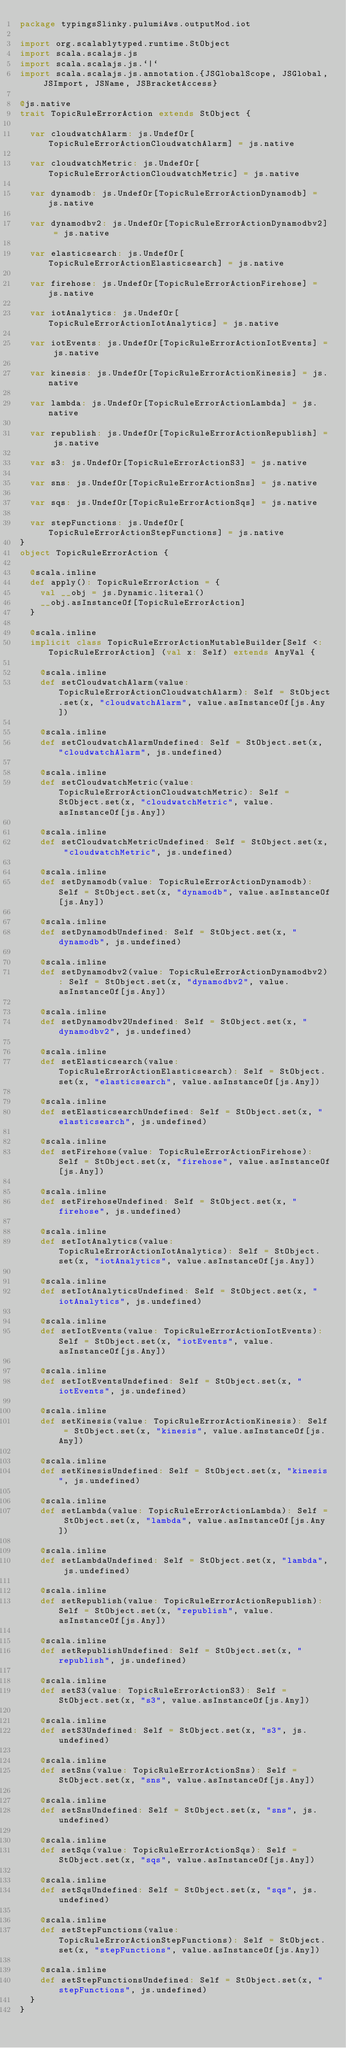Convert code to text. <code><loc_0><loc_0><loc_500><loc_500><_Scala_>package typingsSlinky.pulumiAws.outputMod.iot

import org.scalablytyped.runtime.StObject
import scala.scalajs.js
import scala.scalajs.js.`|`
import scala.scalajs.js.annotation.{JSGlobalScope, JSGlobal, JSImport, JSName, JSBracketAccess}

@js.native
trait TopicRuleErrorAction extends StObject {
  
  var cloudwatchAlarm: js.UndefOr[TopicRuleErrorActionCloudwatchAlarm] = js.native
  
  var cloudwatchMetric: js.UndefOr[TopicRuleErrorActionCloudwatchMetric] = js.native
  
  var dynamodb: js.UndefOr[TopicRuleErrorActionDynamodb] = js.native
  
  var dynamodbv2: js.UndefOr[TopicRuleErrorActionDynamodbv2] = js.native
  
  var elasticsearch: js.UndefOr[TopicRuleErrorActionElasticsearch] = js.native
  
  var firehose: js.UndefOr[TopicRuleErrorActionFirehose] = js.native
  
  var iotAnalytics: js.UndefOr[TopicRuleErrorActionIotAnalytics] = js.native
  
  var iotEvents: js.UndefOr[TopicRuleErrorActionIotEvents] = js.native
  
  var kinesis: js.UndefOr[TopicRuleErrorActionKinesis] = js.native
  
  var lambda: js.UndefOr[TopicRuleErrorActionLambda] = js.native
  
  var republish: js.UndefOr[TopicRuleErrorActionRepublish] = js.native
  
  var s3: js.UndefOr[TopicRuleErrorActionS3] = js.native
  
  var sns: js.UndefOr[TopicRuleErrorActionSns] = js.native
  
  var sqs: js.UndefOr[TopicRuleErrorActionSqs] = js.native
  
  var stepFunctions: js.UndefOr[TopicRuleErrorActionStepFunctions] = js.native
}
object TopicRuleErrorAction {
  
  @scala.inline
  def apply(): TopicRuleErrorAction = {
    val __obj = js.Dynamic.literal()
    __obj.asInstanceOf[TopicRuleErrorAction]
  }
  
  @scala.inline
  implicit class TopicRuleErrorActionMutableBuilder[Self <: TopicRuleErrorAction] (val x: Self) extends AnyVal {
    
    @scala.inline
    def setCloudwatchAlarm(value: TopicRuleErrorActionCloudwatchAlarm): Self = StObject.set(x, "cloudwatchAlarm", value.asInstanceOf[js.Any])
    
    @scala.inline
    def setCloudwatchAlarmUndefined: Self = StObject.set(x, "cloudwatchAlarm", js.undefined)
    
    @scala.inline
    def setCloudwatchMetric(value: TopicRuleErrorActionCloudwatchMetric): Self = StObject.set(x, "cloudwatchMetric", value.asInstanceOf[js.Any])
    
    @scala.inline
    def setCloudwatchMetricUndefined: Self = StObject.set(x, "cloudwatchMetric", js.undefined)
    
    @scala.inline
    def setDynamodb(value: TopicRuleErrorActionDynamodb): Self = StObject.set(x, "dynamodb", value.asInstanceOf[js.Any])
    
    @scala.inline
    def setDynamodbUndefined: Self = StObject.set(x, "dynamodb", js.undefined)
    
    @scala.inline
    def setDynamodbv2(value: TopicRuleErrorActionDynamodbv2): Self = StObject.set(x, "dynamodbv2", value.asInstanceOf[js.Any])
    
    @scala.inline
    def setDynamodbv2Undefined: Self = StObject.set(x, "dynamodbv2", js.undefined)
    
    @scala.inline
    def setElasticsearch(value: TopicRuleErrorActionElasticsearch): Self = StObject.set(x, "elasticsearch", value.asInstanceOf[js.Any])
    
    @scala.inline
    def setElasticsearchUndefined: Self = StObject.set(x, "elasticsearch", js.undefined)
    
    @scala.inline
    def setFirehose(value: TopicRuleErrorActionFirehose): Self = StObject.set(x, "firehose", value.asInstanceOf[js.Any])
    
    @scala.inline
    def setFirehoseUndefined: Self = StObject.set(x, "firehose", js.undefined)
    
    @scala.inline
    def setIotAnalytics(value: TopicRuleErrorActionIotAnalytics): Self = StObject.set(x, "iotAnalytics", value.asInstanceOf[js.Any])
    
    @scala.inline
    def setIotAnalyticsUndefined: Self = StObject.set(x, "iotAnalytics", js.undefined)
    
    @scala.inline
    def setIotEvents(value: TopicRuleErrorActionIotEvents): Self = StObject.set(x, "iotEvents", value.asInstanceOf[js.Any])
    
    @scala.inline
    def setIotEventsUndefined: Self = StObject.set(x, "iotEvents", js.undefined)
    
    @scala.inline
    def setKinesis(value: TopicRuleErrorActionKinesis): Self = StObject.set(x, "kinesis", value.asInstanceOf[js.Any])
    
    @scala.inline
    def setKinesisUndefined: Self = StObject.set(x, "kinesis", js.undefined)
    
    @scala.inline
    def setLambda(value: TopicRuleErrorActionLambda): Self = StObject.set(x, "lambda", value.asInstanceOf[js.Any])
    
    @scala.inline
    def setLambdaUndefined: Self = StObject.set(x, "lambda", js.undefined)
    
    @scala.inline
    def setRepublish(value: TopicRuleErrorActionRepublish): Self = StObject.set(x, "republish", value.asInstanceOf[js.Any])
    
    @scala.inline
    def setRepublishUndefined: Self = StObject.set(x, "republish", js.undefined)
    
    @scala.inline
    def setS3(value: TopicRuleErrorActionS3): Self = StObject.set(x, "s3", value.asInstanceOf[js.Any])
    
    @scala.inline
    def setS3Undefined: Self = StObject.set(x, "s3", js.undefined)
    
    @scala.inline
    def setSns(value: TopicRuleErrorActionSns): Self = StObject.set(x, "sns", value.asInstanceOf[js.Any])
    
    @scala.inline
    def setSnsUndefined: Self = StObject.set(x, "sns", js.undefined)
    
    @scala.inline
    def setSqs(value: TopicRuleErrorActionSqs): Self = StObject.set(x, "sqs", value.asInstanceOf[js.Any])
    
    @scala.inline
    def setSqsUndefined: Self = StObject.set(x, "sqs", js.undefined)
    
    @scala.inline
    def setStepFunctions(value: TopicRuleErrorActionStepFunctions): Self = StObject.set(x, "stepFunctions", value.asInstanceOf[js.Any])
    
    @scala.inline
    def setStepFunctionsUndefined: Self = StObject.set(x, "stepFunctions", js.undefined)
  }
}
</code> 